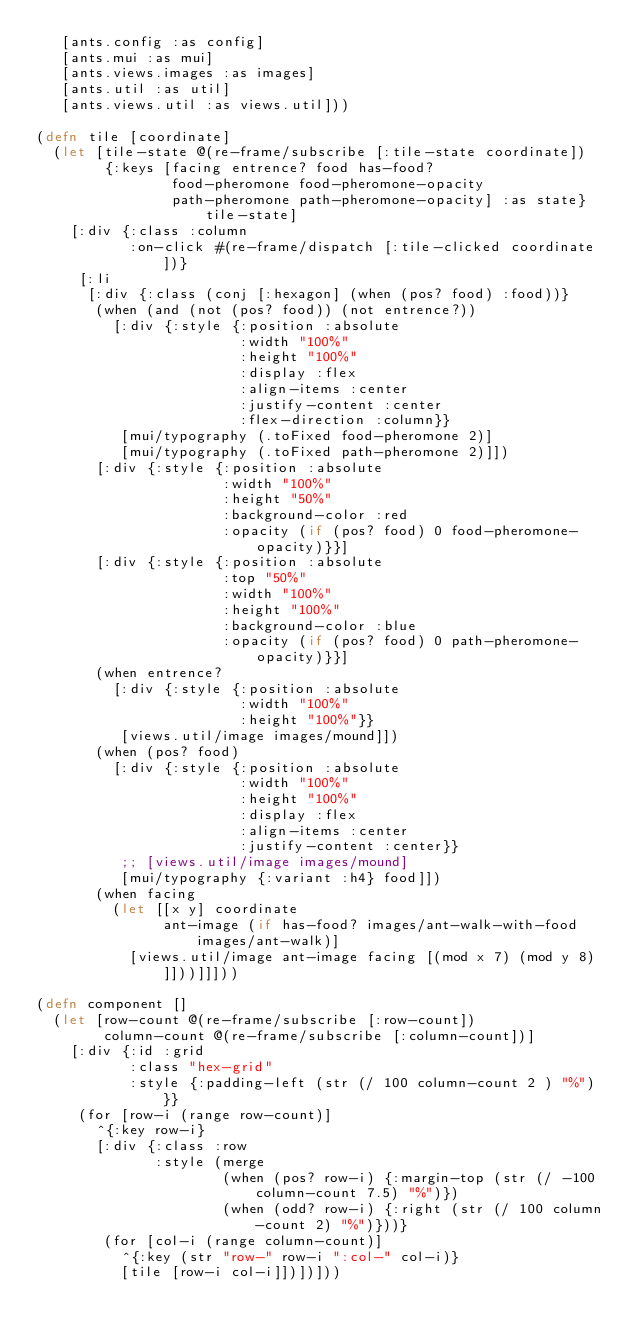<code> <loc_0><loc_0><loc_500><loc_500><_Clojure_>   [ants.config :as config]
   [ants.mui :as mui]
   [ants.views.images :as images]
   [ants.util :as util]
   [ants.views.util :as views.util]))

(defn tile [coordinate]
  (let [tile-state @(re-frame/subscribe [:tile-state coordinate])
        {:keys [facing entrence? food has-food?
                food-pheromone food-pheromone-opacity
                path-pheromone path-pheromone-opacity] :as state} tile-state]
    [:div {:class :column
           :on-click #(re-frame/dispatch [:tile-clicked coordinate])}
     [:li
      [:div {:class (conj [:hexagon] (when (pos? food) :food))}
       (when (and (not (pos? food)) (not entrence?))
         [:div {:style {:position :absolute
                        :width "100%"
                        :height "100%"
                        :display :flex
                        :align-items :center
                        :justify-content :center
                        :flex-direction :column}}
          [mui/typography (.toFixed food-pheromone 2)]
          [mui/typography (.toFixed path-pheromone 2)]])
       [:div {:style {:position :absolute
                      :width "100%"
                      :height "50%"
                      :background-color :red
                      :opacity (if (pos? food) 0 food-pheromone-opacity)}}]
       [:div {:style {:position :absolute
                      :top "50%"
                      :width "100%"
                      :height "100%"
                      :background-color :blue
                      :opacity (if (pos? food) 0 path-pheromone-opacity)}}]
       (when entrence?
         [:div {:style {:position :absolute
                        :width "100%"
                        :height "100%"}}
          [views.util/image images/mound]])
       (when (pos? food)
         [:div {:style {:position :absolute
                        :width "100%"
                        :height "100%"
                        :display :flex
                        :align-items :center
                        :justify-content :center}}
          ;; [views.util/image images/mound]
          [mui/typography {:variant :h4} food]])
       (when facing
         (let [[x y] coordinate
               ant-image (if has-food? images/ant-walk-with-food images/ant-walk)]
           [views.util/image ant-image facing [(mod x 7) (mod y 8)]]))]]]))

(defn component []
  (let [row-count @(re-frame/subscribe [:row-count])
        column-count @(re-frame/subscribe [:column-count])]
    [:div {:id :grid
           :class "hex-grid"
           :style {:padding-left (str (/ 100 column-count 2 ) "%")}}
     (for [row-i (range row-count)]
       ^{:key row-i}
       [:div {:class :row
              :style (merge
                      (when (pos? row-i) {:margin-top (str (/ -100 column-count 7.5) "%")})
                      (when (odd? row-i) {:right (str (/ 100 column-count 2) "%")}))}
        (for [col-i (range column-count)]
          ^{:key (str "row-" row-i ":col-" col-i)}
          [tile [row-i col-i]])])]))

</code> 